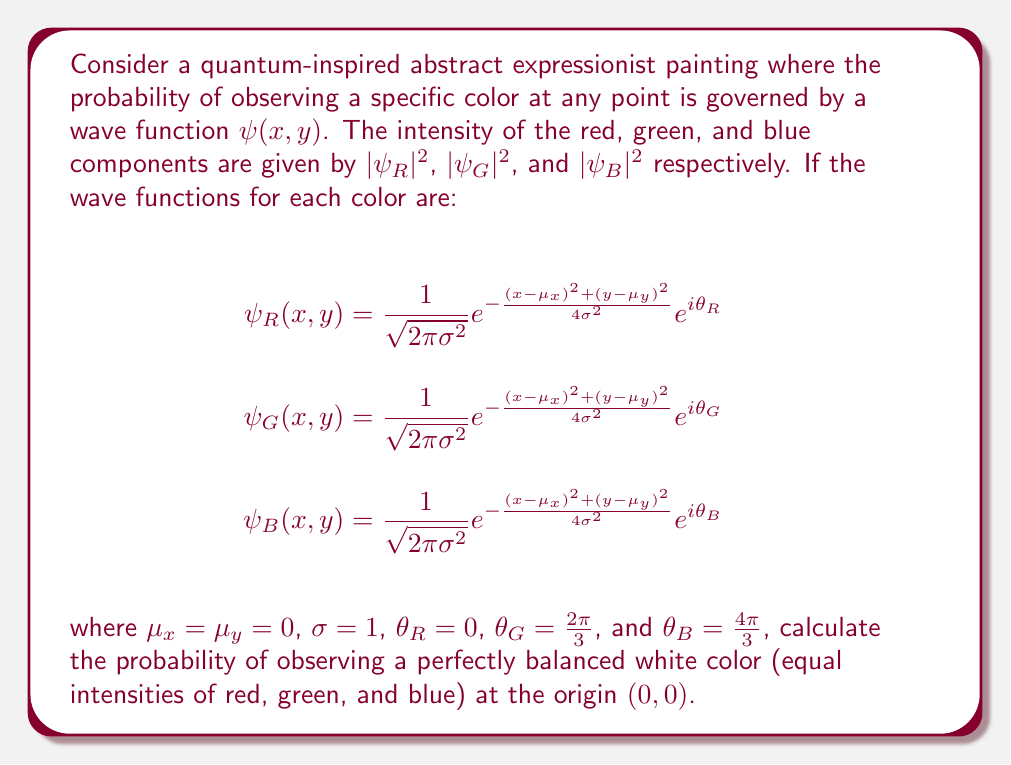Can you solve this math problem? Let's approach this step-by-step:

1) First, we need to calculate the probability density for each color at the origin (0,0). This is given by the squared magnitude of the wave function:

   $P_i(0,0) = |\psi_i(0,0)|^2$, where $i = R, G, B$

2) At the origin, $x = y = 0$, and since $\mu_x = \mu_y = 0$ and $\sigma = 1$, the exponential term becomes:

   $e^{-\frac{(0-0)^2 + (0-0)^2}{4(1)^2}} = e^0 = 1$

3) So, for each color:

   $\psi_i(0,0) = \frac{1}{\sqrt{2\pi}} e^{i\theta_i}$

4) The probability density is:

   $P_i(0,0) = |\psi_i(0,0)|^2 = (\frac{1}{\sqrt{2\pi}})^2 |e^{i\theta_i}|^2 = \frac{1}{2\pi}$

   Note that $|e^{i\theta}| = 1$ for any real $\theta$.

5) For a perfectly balanced white color, we need all three colors to have equal intensity. This means:

   $P_R(0,0) = P_G(0,0) = P_B(0,0) = \frac{1}{2\pi}$

6) The probability of this occurring is the product of the individual probabilities:

   $P(\text{white}) = P_R(0,0) \cdot P_G(0,0) \cdot P_B(0,0) = (\frac{1}{2\pi})^3$

7) Calculating this value:

   $P(\text{white}) = (\frac{1}{2\pi})^3 \approx 0.00405$
Answer: $\frac{1}{8\pi^3} \approx 0.00405$ 